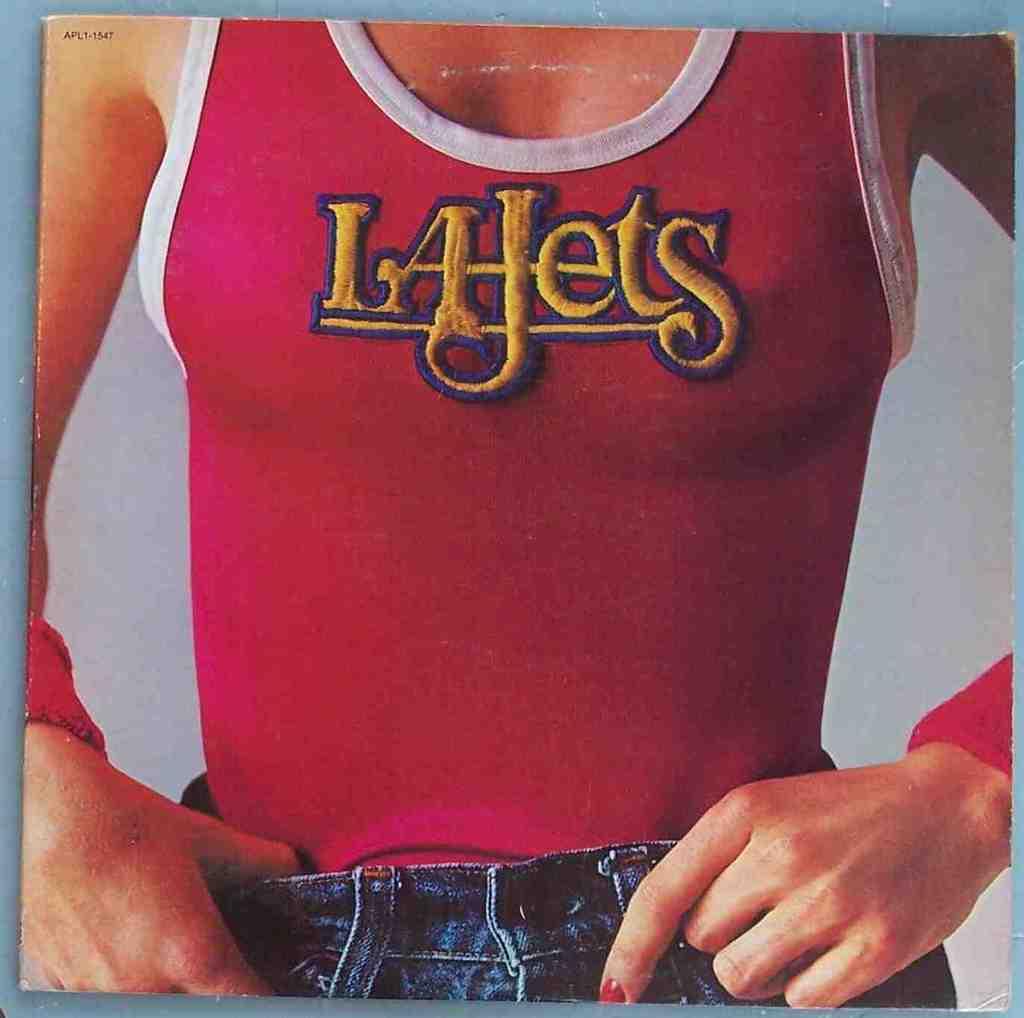What sports team is so amply displayed?
Your answer should be compact. La jets. What letter is in the middle?
Give a very brief answer. J. 